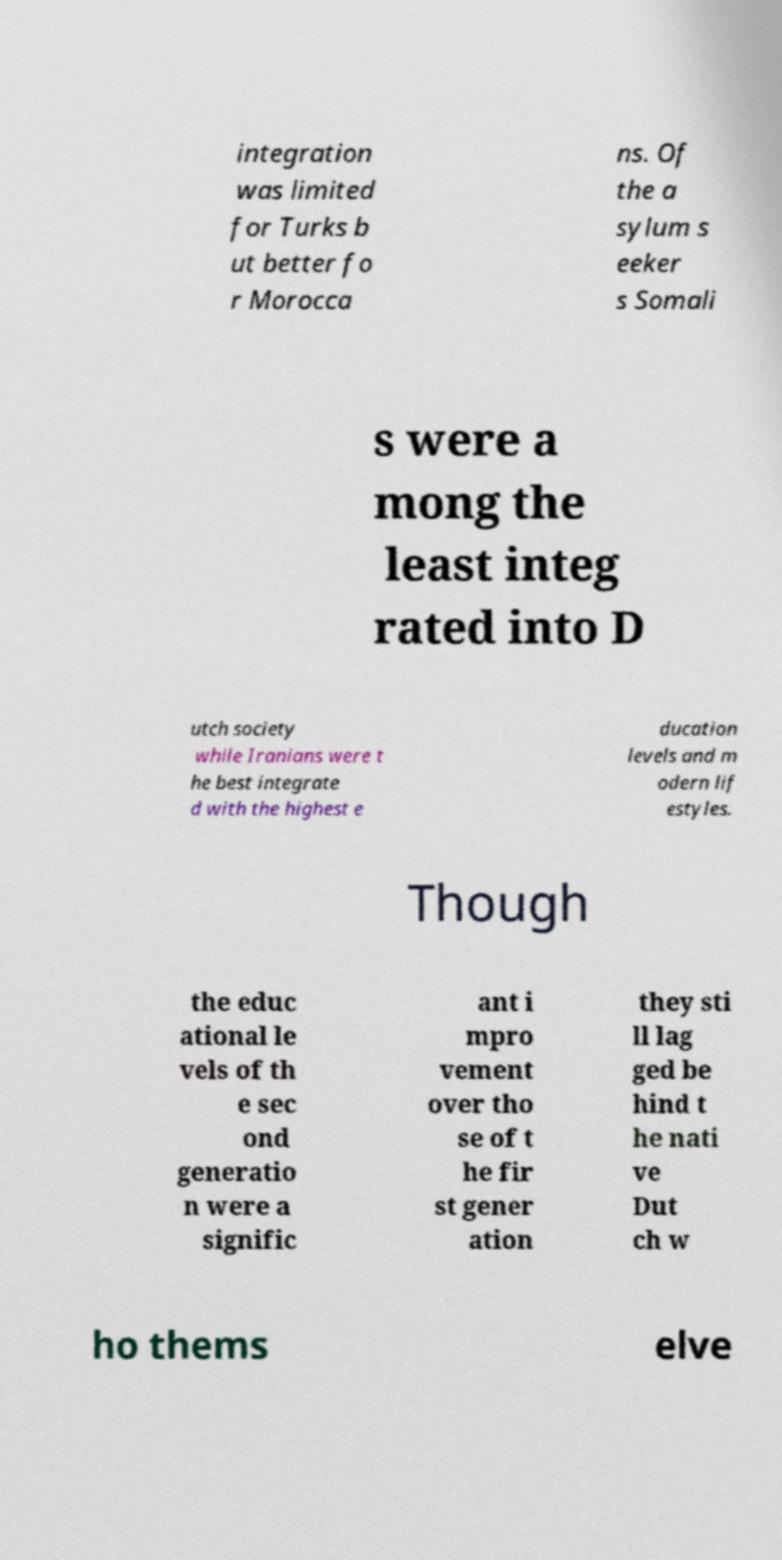Can you read and provide the text displayed in the image?This photo seems to have some interesting text. Can you extract and type it out for me? integration was limited for Turks b ut better fo r Morocca ns. Of the a sylum s eeker s Somali s were a mong the least integ rated into D utch society while Iranians were t he best integrate d with the highest e ducation levels and m odern lif estyles. Though the educ ational le vels of th e sec ond generatio n were a signific ant i mpro vement over tho se of t he fir st gener ation they sti ll lag ged be hind t he nati ve Dut ch w ho thems elve 